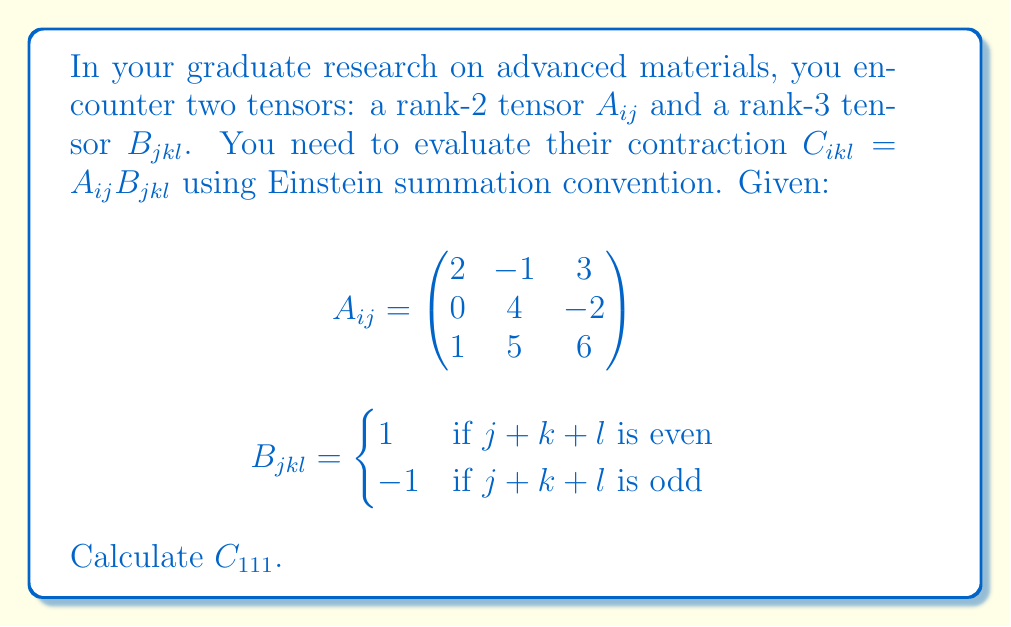Help me with this question. To solve this problem, we'll follow these steps:

1) Understand the Einstein summation convention:
   The repeated index $j$ in $C_{ikl} = A_{ij}B_{jkl}$ implies summation over that index.

2) Expand the expression for $C_{111}$:
   $$C_{111} = A_{1j}B_{j11} = A_{11}B_{111} + A_{12}B_{211} + A_{13}B_{311}$$

3) Evaluate $B_{j11}$ for $j = 1, 2, 3$:
   - $B_{111}$: $1+1+1 = 3$ (odd), so $B_{111} = -1$
   - $B_{211}$: $2+1+1 = 4$ (even), so $B_{211} = 1$
   - $B_{311}$: $3+1+1 = 5$ (odd), so $B_{311} = -1$

4) Substitute the values from $A_{ij}$ and $B_{jkl}$:
   $$C_{111} = (2)(-1) + (-1)(1) + (3)(-1)$$

5) Perform the calculation:
   $$C_{111} = -2 - 1 - 3 = -6$$

Thus, we have evaluated the contraction of the two tensors for the specific case of $C_{111}$.
Answer: $C_{111} = -6$ 